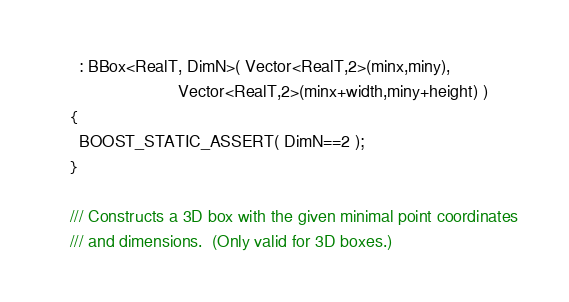Convert code to text. <code><loc_0><loc_0><loc_500><loc_500><_C_>      : BBox<RealT, DimN>( Vector<RealT,2>(minx,miny),
                           Vector<RealT,2>(minx+width,miny+height) )
    {
      BOOST_STATIC_ASSERT( DimN==2 );
    }

    /// Constructs a 3D box with the given minimal point coordinates
    /// and dimensions.  (Only valid for 3D boxes.)</code> 